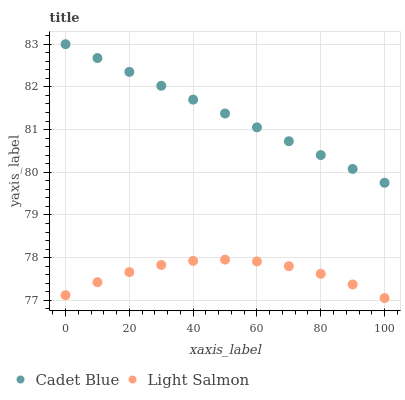Does Light Salmon have the minimum area under the curve?
Answer yes or no. Yes. Does Cadet Blue have the maximum area under the curve?
Answer yes or no. Yes. Does Cadet Blue have the minimum area under the curve?
Answer yes or no. No. Is Cadet Blue the smoothest?
Answer yes or no. Yes. Is Light Salmon the roughest?
Answer yes or no. Yes. Is Cadet Blue the roughest?
Answer yes or no. No. Does Light Salmon have the lowest value?
Answer yes or no. Yes. Does Cadet Blue have the lowest value?
Answer yes or no. No. Does Cadet Blue have the highest value?
Answer yes or no. Yes. Is Light Salmon less than Cadet Blue?
Answer yes or no. Yes. Is Cadet Blue greater than Light Salmon?
Answer yes or no. Yes. Does Light Salmon intersect Cadet Blue?
Answer yes or no. No. 